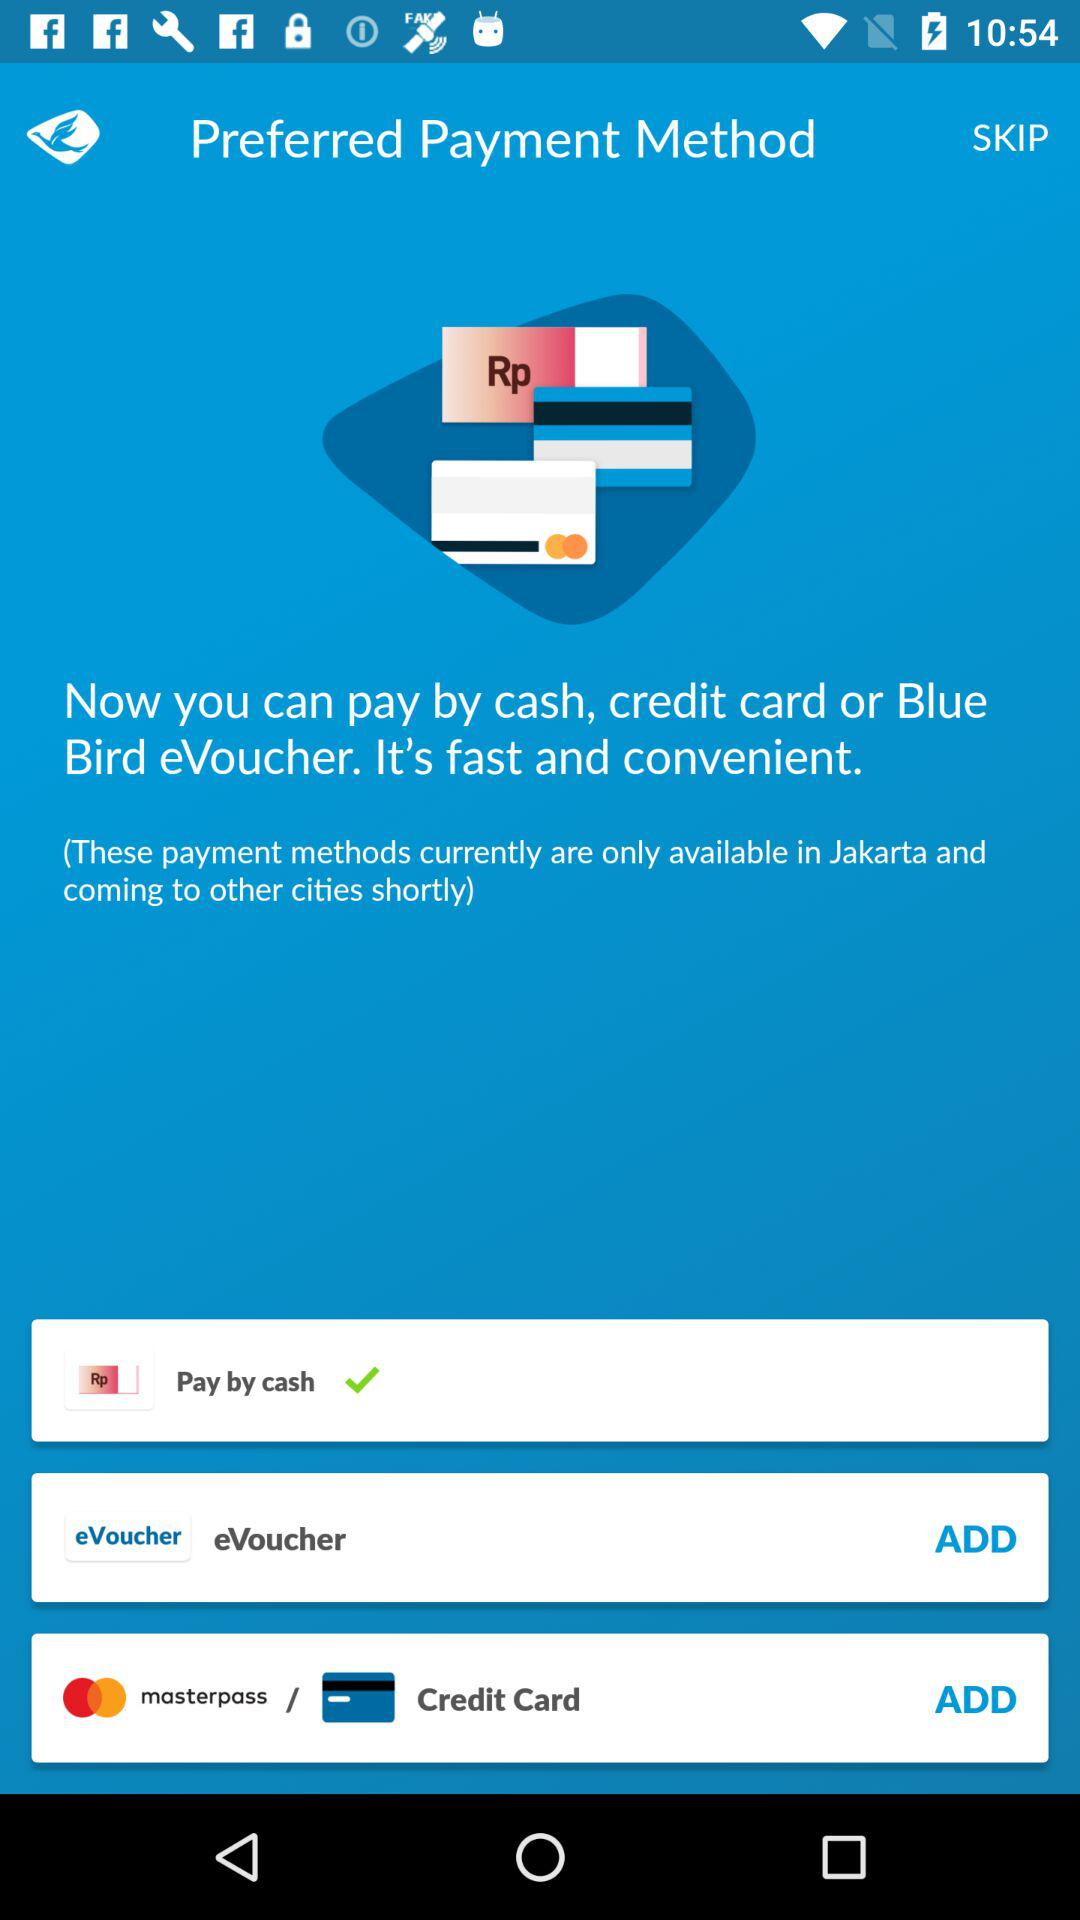How many payment methods are available?
Answer the question using a single word or phrase. 3 